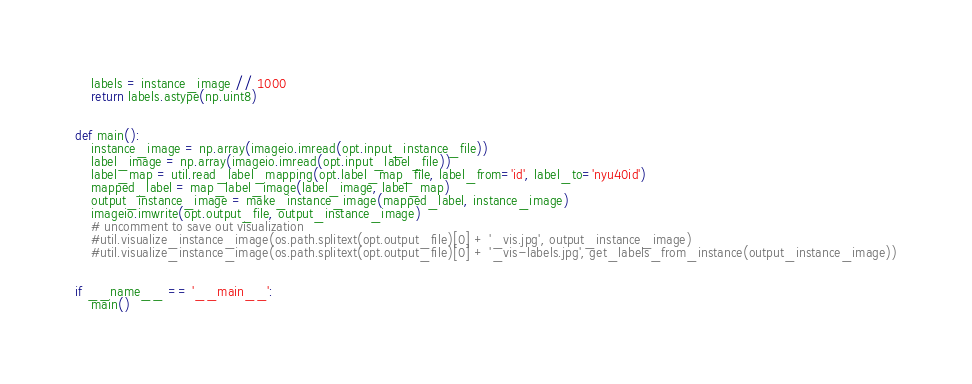<code> <loc_0><loc_0><loc_500><loc_500><_Python_>    labels = instance_image // 1000
    return labels.astype(np.uint8)


def main():
    instance_image = np.array(imageio.imread(opt.input_instance_file))
    label_image = np.array(imageio.imread(opt.input_label_file))
    label_map = util.read_label_mapping(opt.label_map_file, label_from='id', label_to='nyu40id')
    mapped_label = map_label_image(label_image, label_map)
    output_instance_image = make_instance_image(mapped_label, instance_image)
    imageio.imwrite(opt.output_file, output_instance_image)
    # uncomment to save out visualization
    #util.visualize_instance_image(os.path.splitext(opt.output_file)[0] + '_vis.jpg', output_instance_image)
    #util.visualize_instance_image(os.path.splitext(opt.output_file)[0] + '_vis-labels.jpg', get_labels_from_instance(output_instance_image))


if __name__ == '__main__':
    main()


</code> 